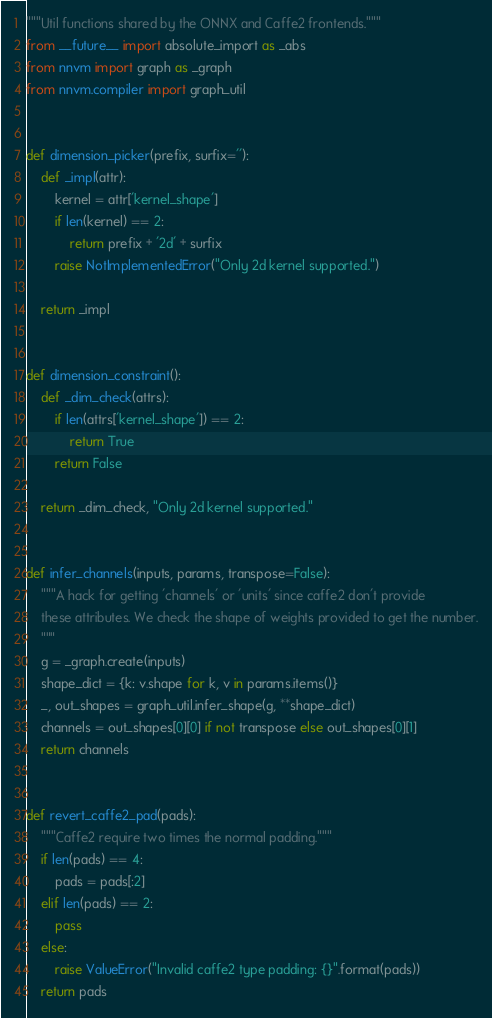<code> <loc_0><loc_0><loc_500><loc_500><_Python_>"""Util functions shared by the ONNX and Caffe2 frontends."""
from __future__ import absolute_import as _abs
from nnvm import graph as _graph
from nnvm.compiler import graph_util


def dimension_picker(prefix, surfix=''):
    def _impl(attr):
        kernel = attr['kernel_shape']
        if len(kernel) == 2:
            return prefix + '2d' + surfix
        raise NotImplementedError("Only 2d kernel supported.")

    return _impl


def dimension_constraint():
    def _dim_check(attrs):
        if len(attrs['kernel_shape']) == 2:
            return True
        return False

    return _dim_check, "Only 2d kernel supported."


def infer_channels(inputs, params, transpose=False):
    """A hack for getting 'channels' or 'units' since caffe2 don't provide
    these attributes. We check the shape of weights provided to get the number.
    """
    g = _graph.create(inputs)
    shape_dict = {k: v.shape for k, v in params.items()}
    _, out_shapes = graph_util.infer_shape(g, **shape_dict)
    channels = out_shapes[0][0] if not transpose else out_shapes[0][1]
    return channels


def revert_caffe2_pad(pads):
    """Caffe2 require two times the normal padding."""
    if len(pads) == 4:
        pads = pads[:2]
    elif len(pads) == 2:
        pass
    else:
        raise ValueError("Invalid caffe2 type padding: {}".format(pads))
    return pads
</code> 